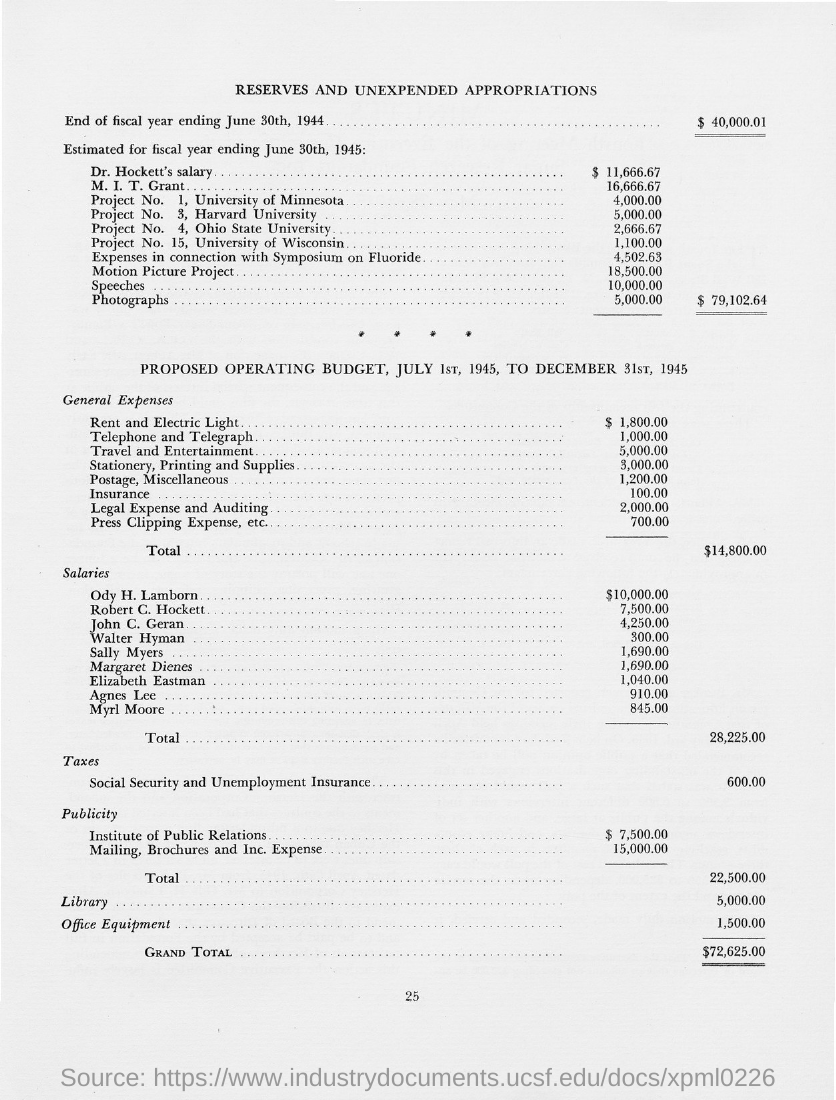What is the document title?
Your response must be concise. Reserves and unexpended appropriations. What is the value "End of fiscal year ending June 30th, 1944?
Your answer should be very brief. $ 40,000.01. What are the general expenses for rent and electric light?
Your answer should be very brief. $ 1,800.00. What is the grand total value?
Offer a very short reply. $72,625.00. What is the page number on this document?
Your response must be concise. 25. 